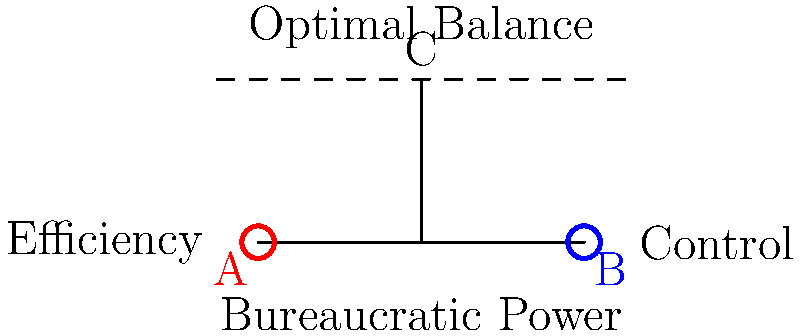In the context of bureaucratic power dynamics, consider the seesaw model above where point A represents efficiency, point B represents control, and point C represents the optimal balance. If a bureaucracy shifts its focus towards increased control measures, how would this affect the overall system, and what philosophical implications might this have for the concept of organizational justice? To answer this question, let's break it down step-by-step:

1. Understanding the model:
   - Point A represents efficiency
   - Point B represents control
   - Point C represents the optimal balance

2. Shifting towards control:
   - This would move the fulcrum (balance point) closer to point B
   - The seesaw would tilt towards the control side

3. Effects on the overall system:
   - Increased control measures may lead to:
     a) More rigid procedures
     b) Stricter oversight
     c) Less flexibility for employees

4. Philosophical implications:
   a) Organizational justice:
      - Procedural justice might increase due to standardized processes
      - Distributive justice could be affected if control hinders fair resource allocation
   
   b) Autonomy vs. Authority:
      - Raises questions about individual freedom within the organization
      - Challenges Kantian notions of human dignity and self-determination

   c) Utilitarianism:
      - Does increased control lead to greater overall utility?
      - Balancing efficiency losses against potential gains in consistency

   d) Social contract theory:
      - How does this shift affect the implicit agreement between the organization and its members?

   e) Power dynamics:
      - Foucauldian analysis of power structures and surveillance
      - Potential for abuse of power in highly controlled environments

5. Ethical considerations:
   - The trade-off between security and liberty in organizational contexts
   - The role of trust in bureaucratic systems

6. Long-term consequences:
   - Potential stifling of innovation and creativity
   - Risk of creating a culture of compliance rather than commitment

The philosophical challenge lies in determining whether this shift towards control can be justified in terms of overall organizational effectiveness and ethical considerations.
Answer: Increased control may enhance procedural justice but risks compromising autonomy, innovation, and overall organizational balance, raising ethical questions about power, justice, and the social contract within bureaucracies. 